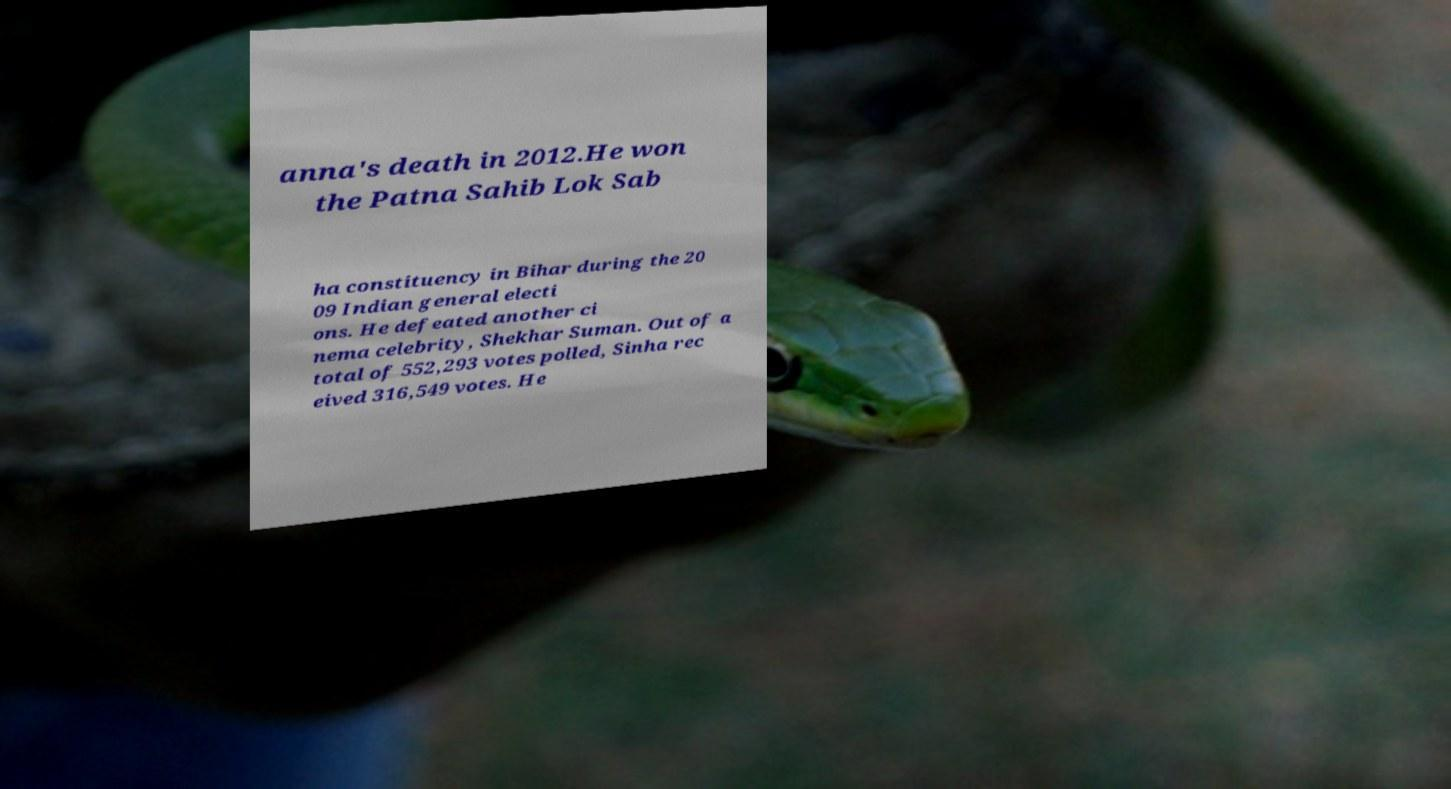There's text embedded in this image that I need extracted. Can you transcribe it verbatim? anna's death in 2012.He won the Patna Sahib Lok Sab ha constituency in Bihar during the 20 09 Indian general electi ons. He defeated another ci nema celebrity, Shekhar Suman. Out of a total of 552,293 votes polled, Sinha rec eived 316,549 votes. He 